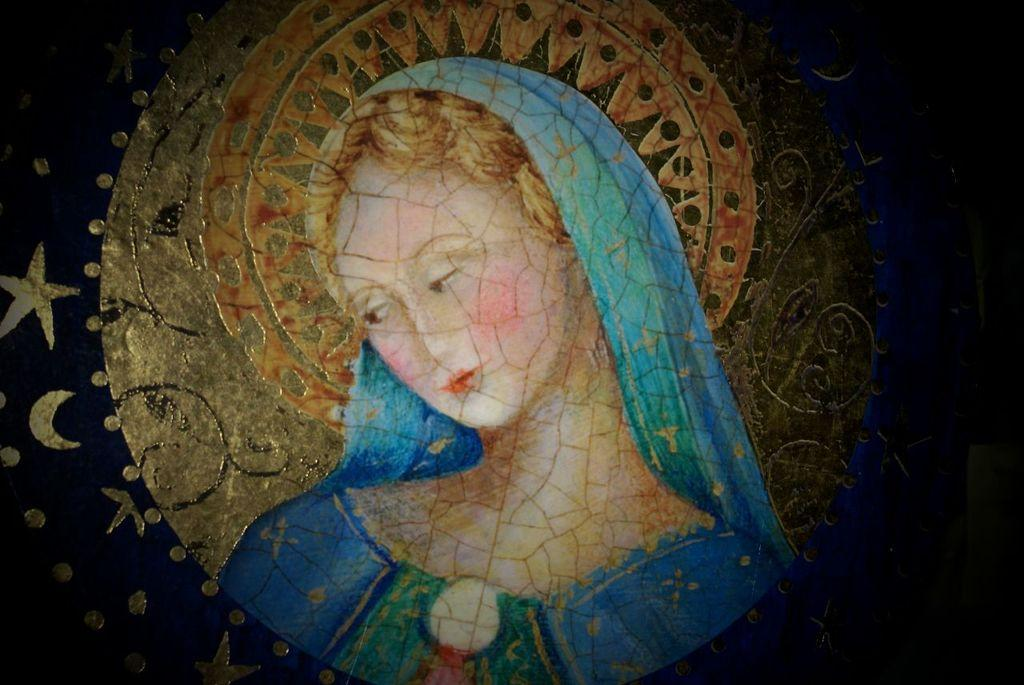Who is in the image? There is a woman in the image. What celestial objects can be seen in the image? Stars and the moon are visible in the image. What is the color and pattern of the surface in the image? There are designs on a blue surface in the image. What type of sticks are being used by the manager in the image? There is no manager or sticks present in the image. 